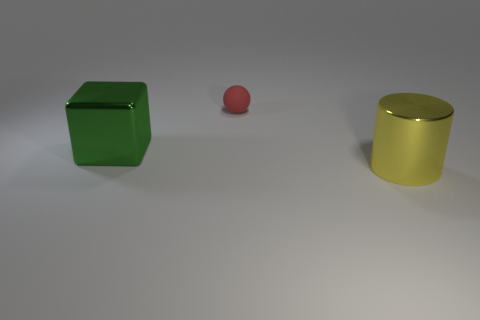There is a shiny object that is on the right side of the green shiny object; what color is it? yellow 